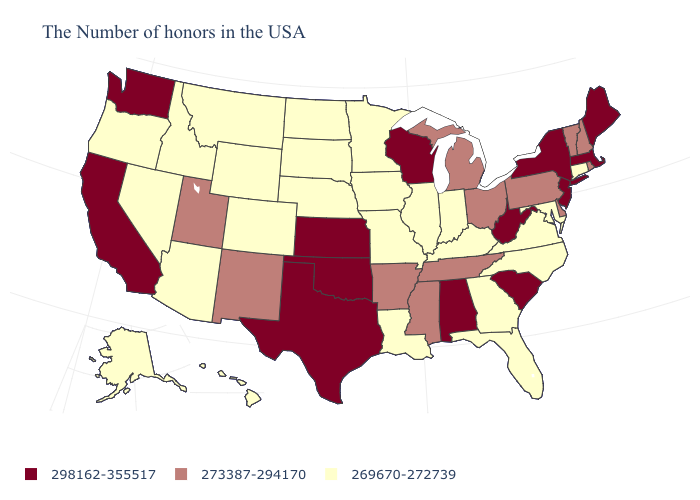Does Texas have the same value as Michigan?
Be succinct. No. What is the value of North Dakota?
Keep it brief. 269670-272739. Name the states that have a value in the range 273387-294170?
Give a very brief answer. Rhode Island, New Hampshire, Vermont, Delaware, Pennsylvania, Ohio, Michigan, Tennessee, Mississippi, Arkansas, New Mexico, Utah. Is the legend a continuous bar?
Give a very brief answer. No. Name the states that have a value in the range 273387-294170?
Be succinct. Rhode Island, New Hampshire, Vermont, Delaware, Pennsylvania, Ohio, Michigan, Tennessee, Mississippi, Arkansas, New Mexico, Utah. Does Minnesota have the highest value in the USA?
Give a very brief answer. No. What is the lowest value in the USA?
Answer briefly. 269670-272739. What is the lowest value in the West?
Be succinct. 269670-272739. Among the states that border Wyoming , does Montana have the lowest value?
Give a very brief answer. Yes. What is the highest value in the USA?
Give a very brief answer. 298162-355517. What is the value of Oregon?
Short answer required. 269670-272739. Name the states that have a value in the range 298162-355517?
Concise answer only. Maine, Massachusetts, New York, New Jersey, South Carolina, West Virginia, Alabama, Wisconsin, Kansas, Oklahoma, Texas, California, Washington. Does Delaware have the lowest value in the USA?
Concise answer only. No. What is the value of South Dakota?
Quick response, please. 269670-272739. What is the value of Iowa?
Write a very short answer. 269670-272739. 